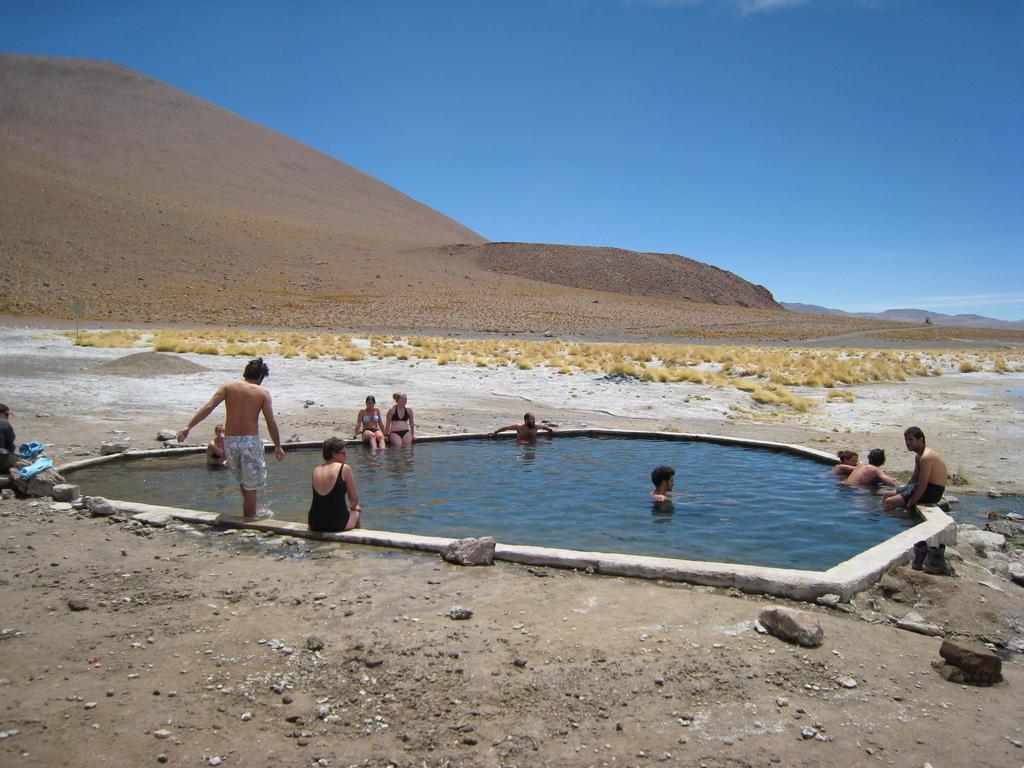Could you give a brief overview of what you see in this image? In this picture, we can see the ground with rocks, grass, and some objects, we can see swimming pool, and a few people, mountains and the sky. 